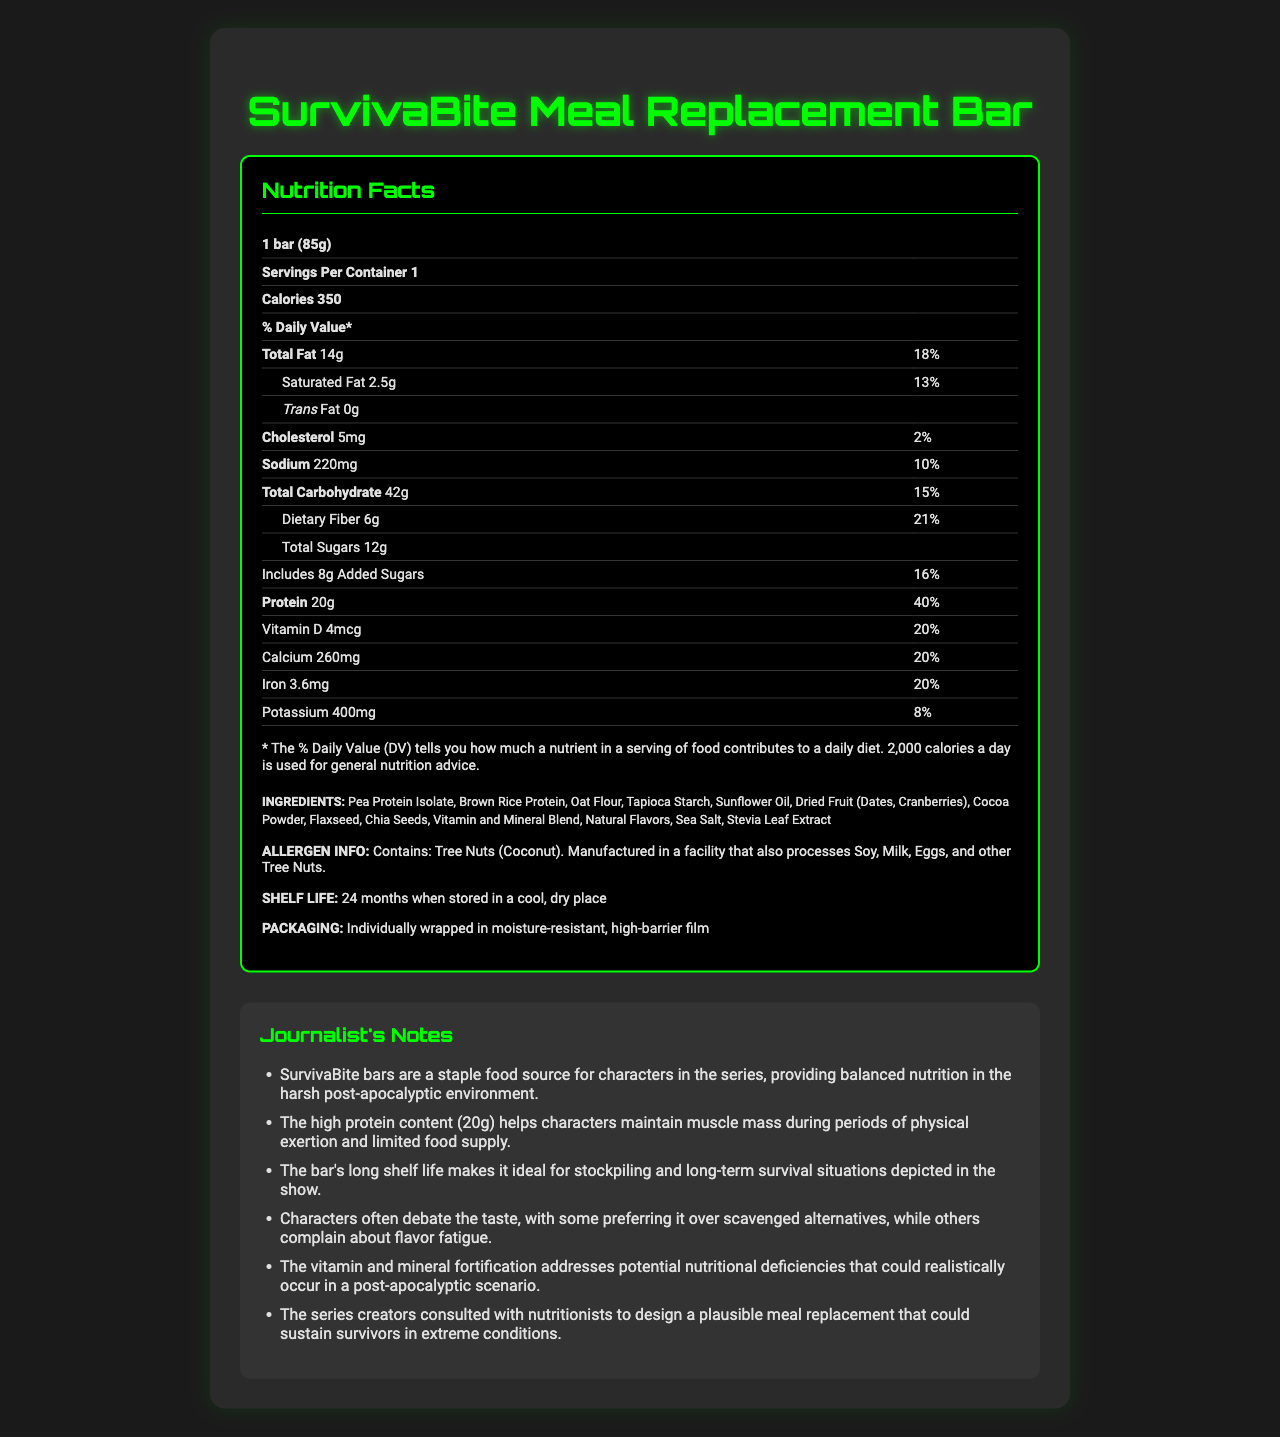What is the serving size of the SurvivaBite Meal Replacement Bar? The serving size is explicitly stated at the beginning of the Nutrition Facts section as "1 bar (85g)".
Answer: 1 bar (85g) How many grams of protein are in one SurvivaBite bar? The amount of protein is listed under the "Protein" section in the Nutrition Facts.
Answer: 20g What percentage of the daily value of dietary fiber does one SurvivaBite bar provide? The daily value percentage is listed next to "Dietary Fiber" in the Nutrition Facts section.
Answer: 21% How many total calories are in one serving of the SurvivaBite bar? The total number of calories per serving is stated as "Calories 350" in the Nutrition Facts section.
Answer: 350 What is the shelf life of the SurvivaBite bar? The shelf life information is provided under the "Shelf Life" section.
Answer: 24 months when stored in a cool, dry place Does the SurvivaBite bar contain trans fat? The amount of trans fat is listed as "0g" in the Nutrition Facts section.
Answer: No What is the amount of Vitamin D in one SurvivaBite bar? A. 2mcg B. 4mcg C. 6mcg D. 8mcg The Nutrition Facts section lists Vitamin D as "4mcg".
Answer: B. 4mcg Which of the following is NOT an ingredient in the SurvivaBite bar? I. Pea Protein Isolate II. Brown Rice Protein III. Wheat Flour IV. Oat Flour The ingredient list does not include Wheat Flour but does mention Pea Protein Isolate, Brown Rice Protein, and Oat Flour.
Answer: III. Wheat Flour Is the amount of saturated fat in the SurvivaBite bar more than 15% of the daily value? The daily value percentage of saturated fat is listed as "13%" in the Nutrition Facts section.
Answer: No What allergens are present in the SurvivaBite bar? The allergen information specifies it contains Tree Nuts (Coconut).
Answer: Tree Nuts (Coconut) Summarize the main nutritional benefits of the SurvivaBite Meal Replacement Bar. The bar provides a high amount of protein and dietary fiber, along with a range of vitamins and minerals, and is free from trans fat. Its long shelf life makes it suitable for stockpiling in survival situations.
Answer: The SurvivaBite Meal Replacement Bar provides a balanced nutrition profile with 20g of protein, 21% of daily dietary fiber, and significant daily values of essential vitamins and minerals. It contains no trans fat, moderate calories, and comes with a long shelf life, making it ideal for survival situations. What is the percentage of daily value for Iron in one bar? The daily value percentage for Iron is listed as "20%" in the Nutrition Facts section.
Answer: 20% How much sodium does one SurvivaBite bar contain? The amount of sodium is listed as "220mg" in the Nutrition Facts section.
Answer: 220mg What reason did the series creators have for consulting nutritionists during the design of the SurvivaBite bar? The journalist notes mention that the series creators worked with nutritionists to ensure the meal replacement bar would be suitable for survival scenarios.
Answer: The series creators consulted with nutritionists to design a plausible meal replacement that could sustain survivors in extreme conditions. How many grams of total sugars are in one SurvivaBite bar? The total grams of sugars are listed as "12g" in the Nutrition Facts section.
Answer: 12g What is the main source of carbohydrates in the SurvivaBite bar? The document does not specify the main source of carbohydrates.
Answer: Not enough information 